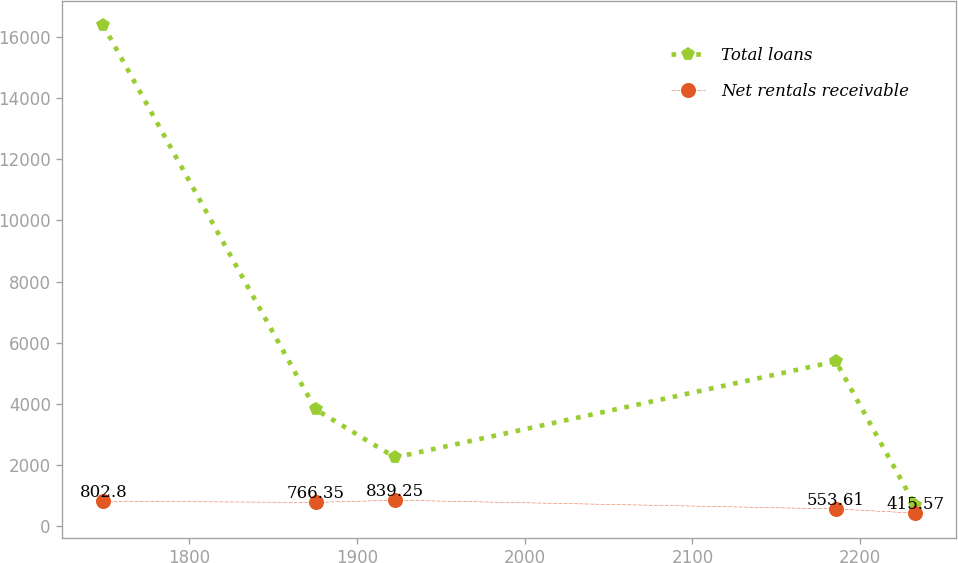Convert chart. <chart><loc_0><loc_0><loc_500><loc_500><line_chart><ecel><fcel>Total loans<fcel>Net rentals receivable<nl><fcel>1748.83<fcel>16398.8<fcel>802.8<nl><fcel>1875.45<fcel>3812.2<fcel>766.35<nl><fcel>1922.82<fcel>2238.88<fcel>839.25<nl><fcel>2185.48<fcel>5385.52<fcel>553.61<nl><fcel>2232.85<fcel>665.56<fcel>415.57<nl></chart> 